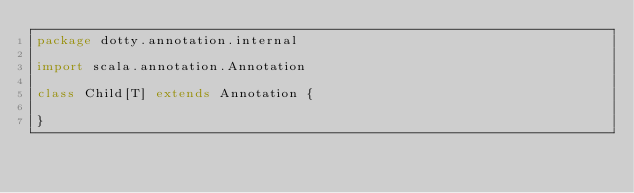<code> <loc_0><loc_0><loc_500><loc_500><_Scala_>package dotty.annotation.internal

import scala.annotation.Annotation

class Child[T] extends Annotation {

}
</code> 